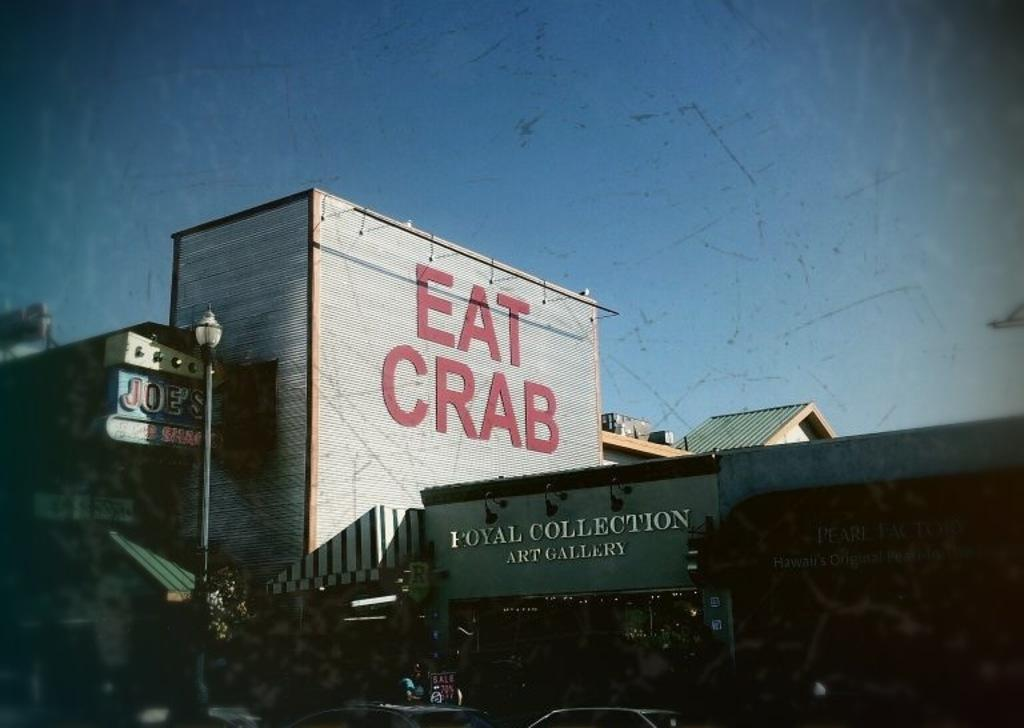What type of structure is present in the image? There is a building in the image. What might the building be used for? The building appears to be an art gallery. What can be seen above the building in the image? The sky is visible above the building. Can you see your dad holding a crayon and a feather in the image? There is no person, including your dad, present in the image. Additionally, there are no crayons or feathers visible. 